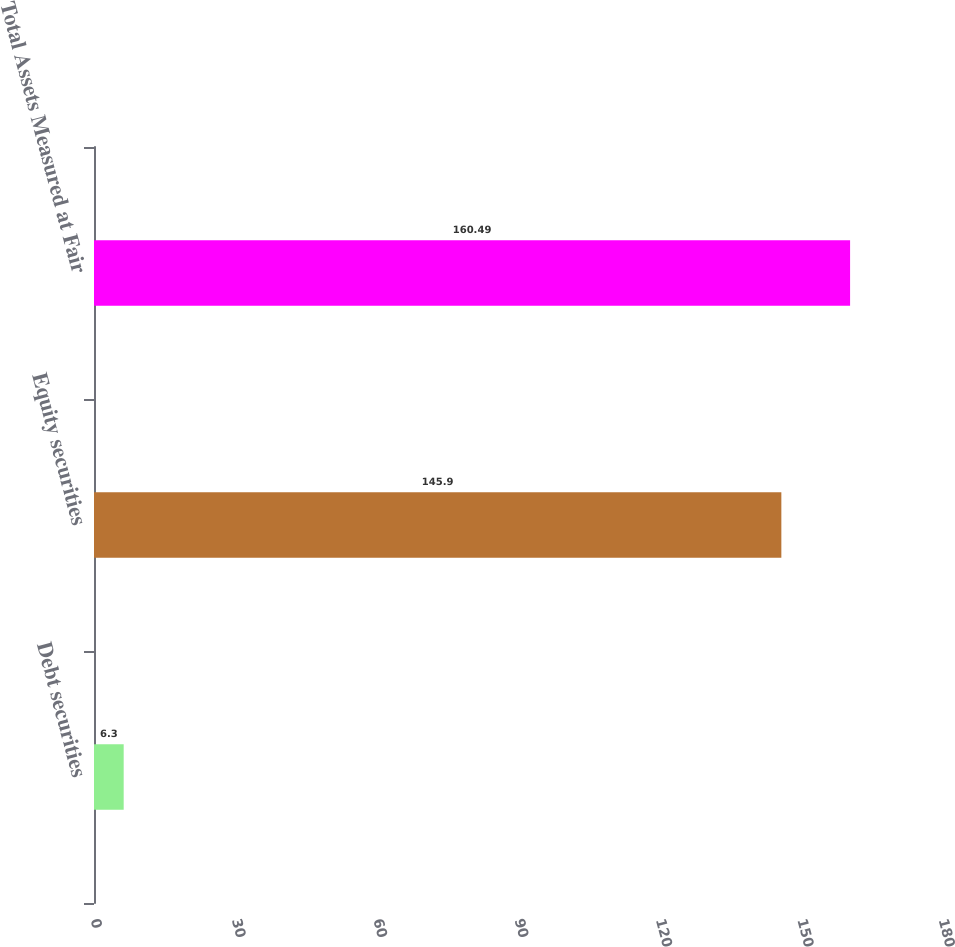Convert chart. <chart><loc_0><loc_0><loc_500><loc_500><bar_chart><fcel>Debt securities<fcel>Equity securities<fcel>Total Assets Measured at Fair<nl><fcel>6.3<fcel>145.9<fcel>160.49<nl></chart> 